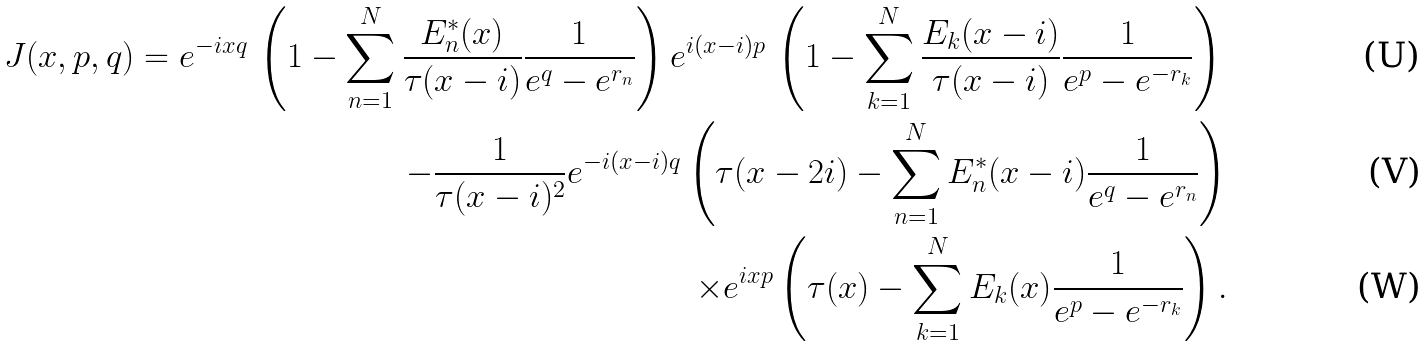<formula> <loc_0><loc_0><loc_500><loc_500>J ( x , p , q ) = e ^ { - i x q } \, \left ( 1 - \sum _ { n = 1 } ^ { N } \frac { E _ { n } ^ { * } ( x ) } { \tau ( x - i ) } \frac { 1 } { e ^ { q } - e ^ { r _ { n } } } \right ) e ^ { i ( x - i ) p } \, \left ( 1 - \sum _ { k = 1 } ^ { N } \frac { E _ { k } ( x - i ) } { \tau ( x - i ) } \frac { 1 } { e ^ { p } - e ^ { - r _ { k } } } \right ) \, \\ - \frac { 1 } { \tau ( x - i ) ^ { 2 } } e ^ { - i ( x - i ) q } \left ( \tau ( x - 2 i ) - \sum _ { n = 1 } ^ { N } E _ { n } ^ { * } ( x - i ) \frac { 1 } { e ^ { q } - e ^ { r _ { n } } } \right ) \\ \times e ^ { i x p } \left ( \tau ( x ) - \sum _ { k = 1 } ^ { N } E _ { k } ( x ) \frac { 1 } { e ^ { p } - e ^ { - r _ { k } } } \right ) .</formula> 